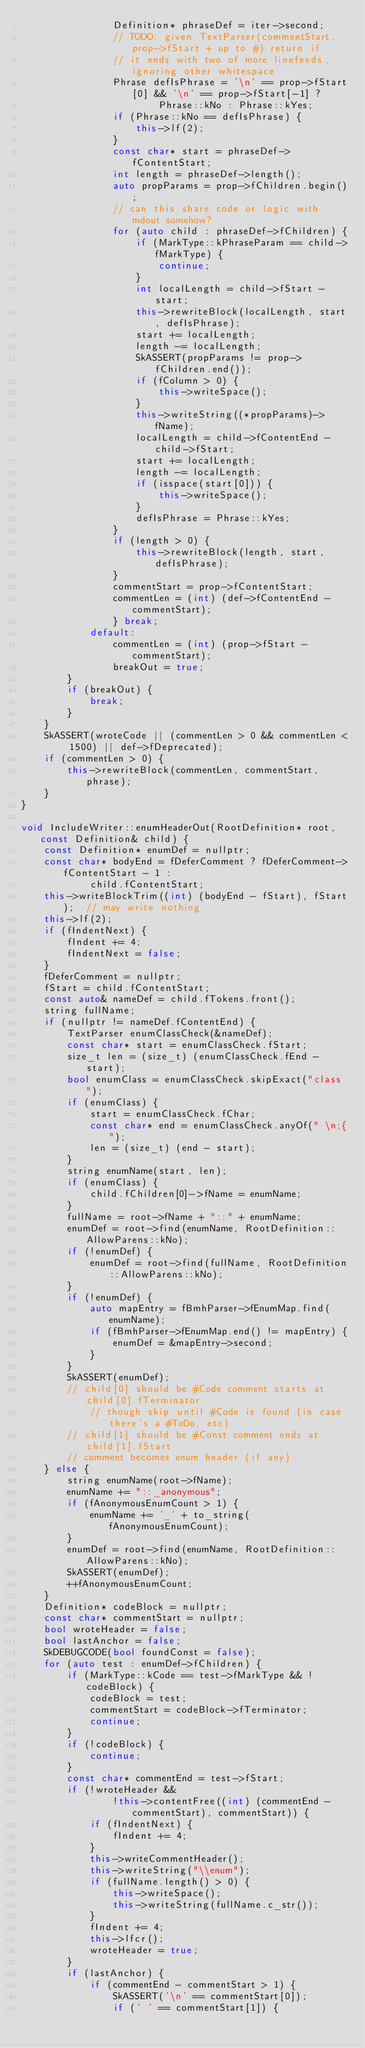<code> <loc_0><loc_0><loc_500><loc_500><_C++_>                Definition* phraseDef = iter->second;
                // TODO: given TextParser(commentStart, prop->fStart + up to #) return if
                // it ends with two of more linefeeds, ignoring other whitespace
                Phrase defIsPhrase = '\n' == prop->fStart[0] && '\n' == prop->fStart[-1] ?
                        Phrase::kNo : Phrase::kYes;
                if (Phrase::kNo == defIsPhrase) {
                    this->lf(2);
                }
                const char* start = phraseDef->fContentStart;
                int length = phraseDef->length();
                auto propParams = prop->fChildren.begin();
                // can this share code or logic with mdout somehow?
                for (auto child : phraseDef->fChildren) {
                    if (MarkType::kPhraseParam == child->fMarkType) {
                        continue;
                    }
                    int localLength = child->fStart - start;
                    this->rewriteBlock(localLength, start, defIsPhrase);
                    start += localLength;
                    length -= localLength;
                    SkASSERT(propParams != prop->fChildren.end());
                    if (fColumn > 0) {
                        this->writeSpace();
                    }
                    this->writeString((*propParams)->fName);
                    localLength = child->fContentEnd - child->fStart;
                    start += localLength;
                    length -= localLength;
                    if (isspace(start[0])) {
                        this->writeSpace();
                    }
                    defIsPhrase = Phrase::kYes;
                }
                if (length > 0) {
                    this->rewriteBlock(length, start, defIsPhrase);
                }
                commentStart = prop->fContentStart;
                commentLen = (int) (def->fContentEnd - commentStart);
                } break;
            default:
                commentLen = (int) (prop->fStart - commentStart);
                breakOut = true;
        }
        if (breakOut) {
            break;
        }
    }
    SkASSERT(wroteCode || (commentLen > 0 && commentLen < 1500) || def->fDeprecated);
    if (commentLen > 0) {
        this->rewriteBlock(commentLen, commentStart, phrase);
    }
}

void IncludeWriter::enumHeaderOut(RootDefinition* root, const Definition& child) {
    const Definition* enumDef = nullptr;
    const char* bodyEnd = fDeferComment ? fDeferComment->fContentStart - 1 :
            child.fContentStart;
    this->writeBlockTrim((int) (bodyEnd - fStart), fStart);  // may write nothing
    this->lf(2);
    if (fIndentNext) {
        fIndent += 4;
        fIndentNext = false;
    }
    fDeferComment = nullptr;
    fStart = child.fContentStart;
    const auto& nameDef = child.fTokens.front();
    string fullName;
    if (nullptr != nameDef.fContentEnd) {
        TextParser enumClassCheck(&nameDef);
        const char* start = enumClassCheck.fStart;
        size_t len = (size_t) (enumClassCheck.fEnd - start);
        bool enumClass = enumClassCheck.skipExact("class ");
        if (enumClass) {
            start = enumClassCheck.fChar;
            const char* end = enumClassCheck.anyOf(" \n;{");
            len = (size_t) (end - start);
        }
        string enumName(start, len);
        if (enumClass) {
            child.fChildren[0]->fName = enumName;
        }
        fullName = root->fName + "::" + enumName;
        enumDef = root->find(enumName, RootDefinition::AllowParens::kNo);
        if (!enumDef) {
            enumDef = root->find(fullName, RootDefinition::AllowParens::kNo);
        }
        if (!enumDef) {
            auto mapEntry = fBmhParser->fEnumMap.find(enumName);
            if (fBmhParser->fEnumMap.end() != mapEntry) {
                enumDef = &mapEntry->second;
            }
        }
        SkASSERT(enumDef);
        // child[0] should be #Code comment starts at child[0].fTerminator
            // though skip until #Code is found (in case there's a #ToDo, etc)
        // child[1] should be #Const comment ends at child[1].fStart
        // comment becomes enum header (if any)
    } else {
        string enumName(root->fName);
        enumName += "::_anonymous";
        if (fAnonymousEnumCount > 1) {
            enumName += '_' + to_string(fAnonymousEnumCount);
        }
        enumDef = root->find(enumName, RootDefinition::AllowParens::kNo);
        SkASSERT(enumDef);
        ++fAnonymousEnumCount;
    }
    Definition* codeBlock = nullptr;
    const char* commentStart = nullptr;
    bool wroteHeader = false;
    bool lastAnchor = false;
    SkDEBUGCODE(bool foundConst = false);
    for (auto test : enumDef->fChildren) {
        if (MarkType::kCode == test->fMarkType && !codeBlock) {
            codeBlock = test;
            commentStart = codeBlock->fTerminator;
            continue;
        }
        if (!codeBlock) {
            continue;
        }
        const char* commentEnd = test->fStart;
        if (!wroteHeader &&
                !this->contentFree((int) (commentEnd - commentStart), commentStart)) {
            if (fIndentNext) {
                fIndent += 4;
            }
            this->writeCommentHeader();
            this->writeString("\\enum");
            if (fullName.length() > 0) {
                this->writeSpace();
                this->writeString(fullName.c_str());
            }
            fIndent += 4;
            this->lfcr();
            wroteHeader = true;
        }
        if (lastAnchor) {
            if (commentEnd - commentStart > 1) {
                SkASSERT('\n' == commentStart[0]);
                if (' ' == commentStart[1]) {</code> 